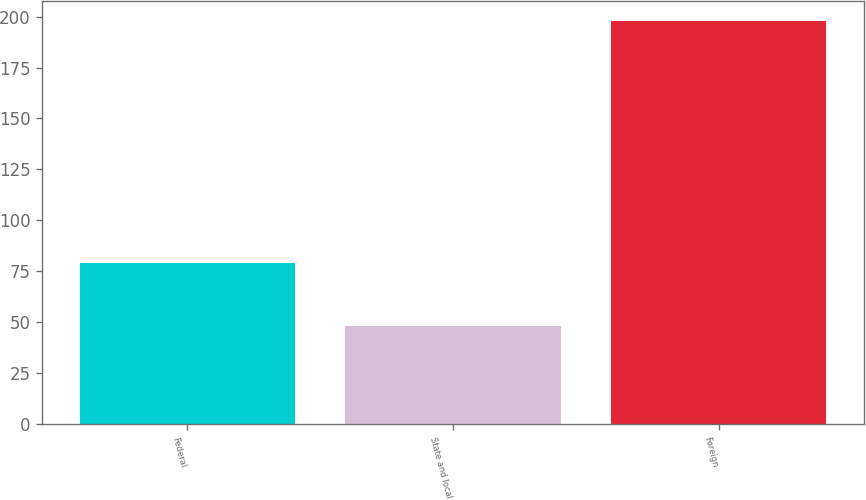Convert chart to OTSL. <chart><loc_0><loc_0><loc_500><loc_500><bar_chart><fcel>Federal<fcel>State and local<fcel>Foreign<nl><fcel>79<fcel>48<fcel>198<nl></chart> 